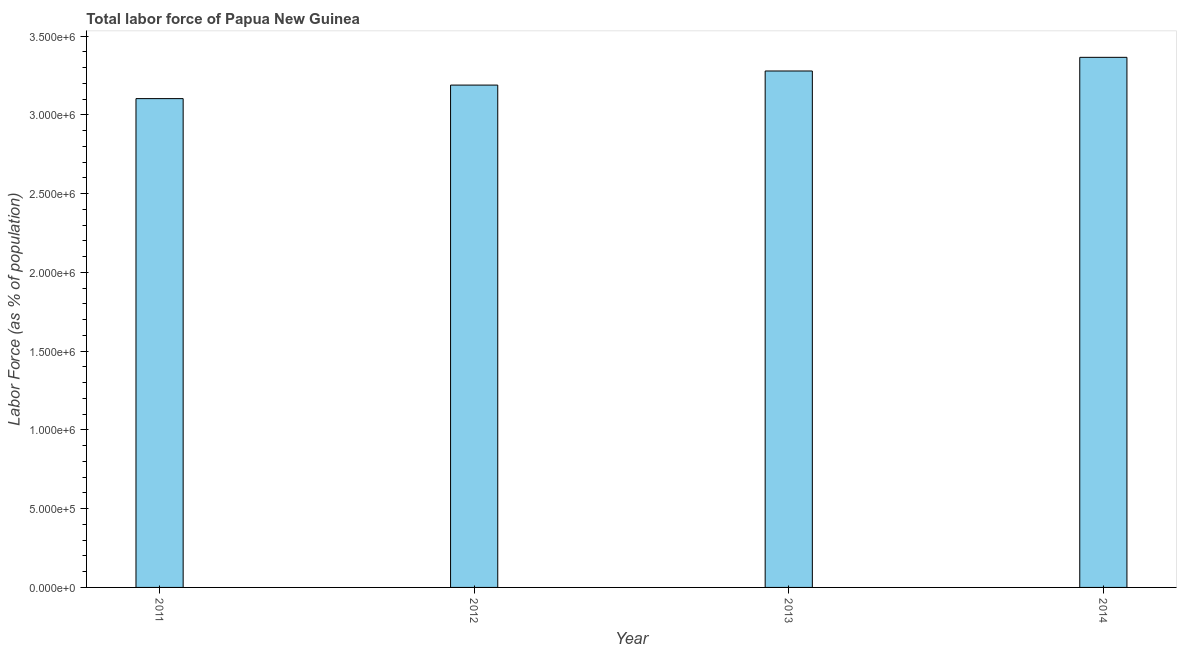Does the graph contain any zero values?
Your answer should be very brief. No. Does the graph contain grids?
Your answer should be compact. No. What is the title of the graph?
Your response must be concise. Total labor force of Papua New Guinea. What is the label or title of the Y-axis?
Your answer should be compact. Labor Force (as % of population). What is the total labor force in 2014?
Keep it short and to the point. 3.37e+06. Across all years, what is the maximum total labor force?
Your answer should be very brief. 3.37e+06. Across all years, what is the minimum total labor force?
Your response must be concise. 3.10e+06. In which year was the total labor force maximum?
Keep it short and to the point. 2014. In which year was the total labor force minimum?
Provide a succinct answer. 2011. What is the sum of the total labor force?
Provide a short and direct response. 1.29e+07. What is the difference between the total labor force in 2012 and 2013?
Keep it short and to the point. -8.95e+04. What is the average total labor force per year?
Provide a succinct answer. 3.23e+06. What is the median total labor force?
Your response must be concise. 3.23e+06. Do a majority of the years between 2014 and 2012 (inclusive) have total labor force greater than 2100000 %?
Offer a terse response. Yes. What is the ratio of the total labor force in 2011 to that in 2014?
Offer a very short reply. 0.92. Is the total labor force in 2012 less than that in 2013?
Ensure brevity in your answer.  Yes. What is the difference between the highest and the second highest total labor force?
Your answer should be very brief. 8.67e+04. Is the sum of the total labor force in 2012 and 2013 greater than the maximum total labor force across all years?
Your answer should be very brief. Yes. What is the difference between the highest and the lowest total labor force?
Give a very brief answer. 2.62e+05. In how many years, is the total labor force greater than the average total labor force taken over all years?
Ensure brevity in your answer.  2. What is the difference between two consecutive major ticks on the Y-axis?
Your response must be concise. 5.00e+05. Are the values on the major ticks of Y-axis written in scientific E-notation?
Give a very brief answer. Yes. What is the Labor Force (as % of population) in 2011?
Ensure brevity in your answer.  3.10e+06. What is the Labor Force (as % of population) of 2012?
Your answer should be compact. 3.19e+06. What is the Labor Force (as % of population) of 2013?
Ensure brevity in your answer.  3.28e+06. What is the Labor Force (as % of population) of 2014?
Your answer should be very brief. 3.37e+06. What is the difference between the Labor Force (as % of population) in 2011 and 2012?
Offer a very short reply. -8.60e+04. What is the difference between the Labor Force (as % of population) in 2011 and 2013?
Ensure brevity in your answer.  -1.76e+05. What is the difference between the Labor Force (as % of population) in 2011 and 2014?
Make the answer very short. -2.62e+05. What is the difference between the Labor Force (as % of population) in 2012 and 2013?
Your response must be concise. -8.95e+04. What is the difference between the Labor Force (as % of population) in 2012 and 2014?
Ensure brevity in your answer.  -1.76e+05. What is the difference between the Labor Force (as % of population) in 2013 and 2014?
Keep it short and to the point. -8.67e+04. What is the ratio of the Labor Force (as % of population) in 2011 to that in 2012?
Offer a terse response. 0.97. What is the ratio of the Labor Force (as % of population) in 2011 to that in 2013?
Give a very brief answer. 0.95. What is the ratio of the Labor Force (as % of population) in 2011 to that in 2014?
Your response must be concise. 0.92. What is the ratio of the Labor Force (as % of population) in 2012 to that in 2013?
Give a very brief answer. 0.97. What is the ratio of the Labor Force (as % of population) in 2012 to that in 2014?
Provide a short and direct response. 0.95. 